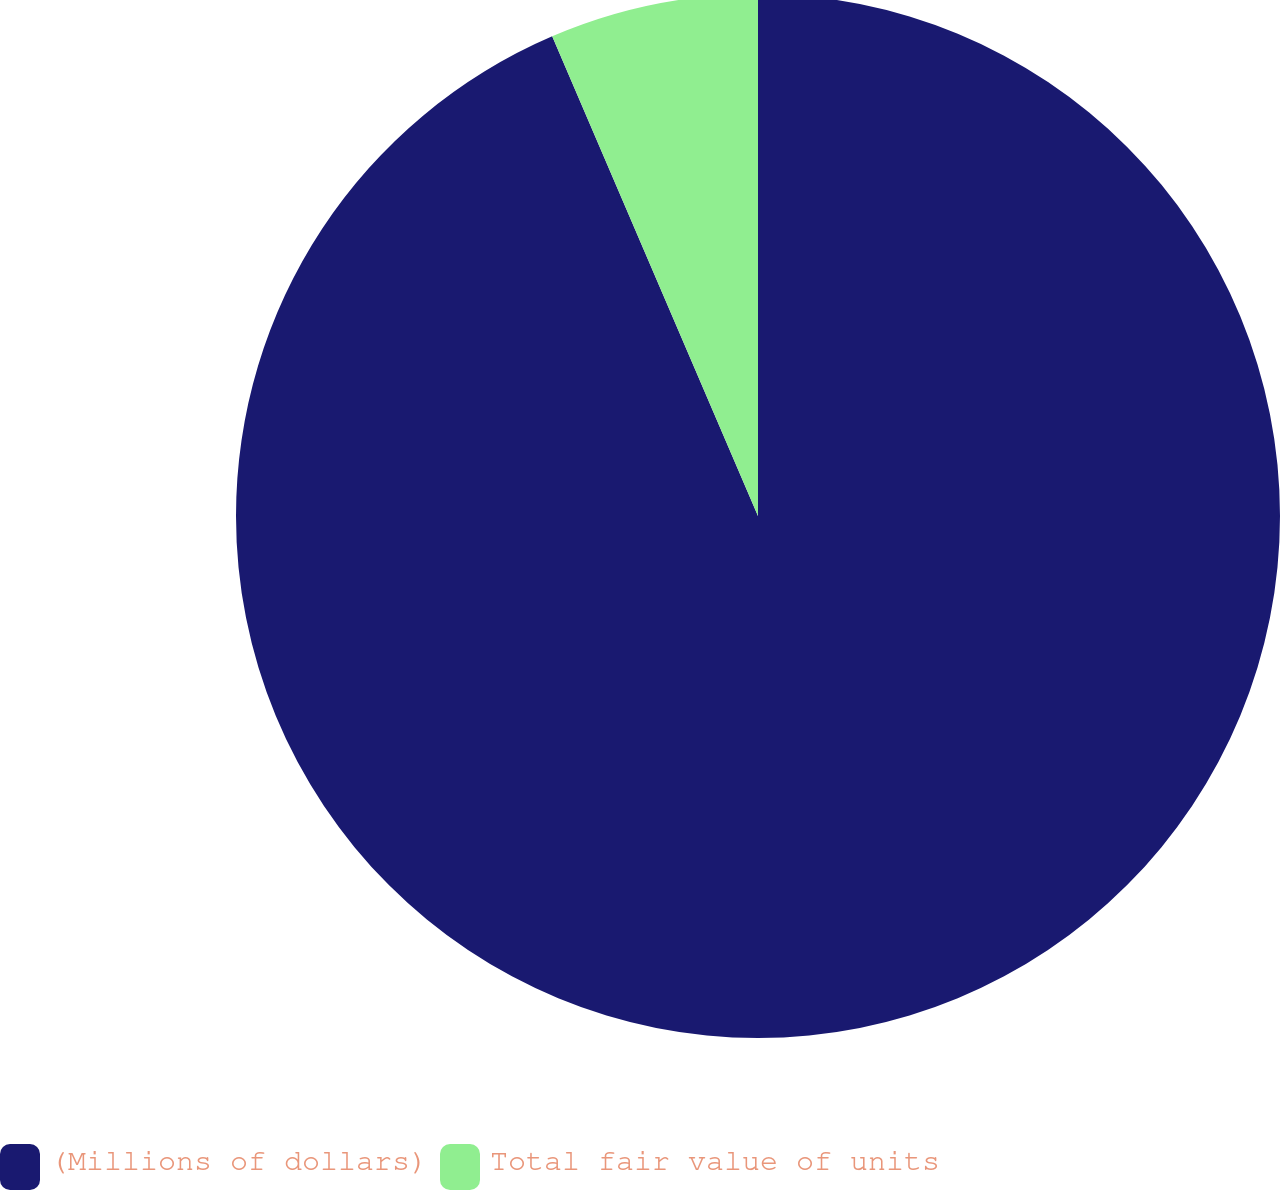Convert chart. <chart><loc_0><loc_0><loc_500><loc_500><pie_chart><fcel>(Millions of dollars)<fcel>Total fair value of units<nl><fcel>93.55%<fcel>6.45%<nl></chart> 